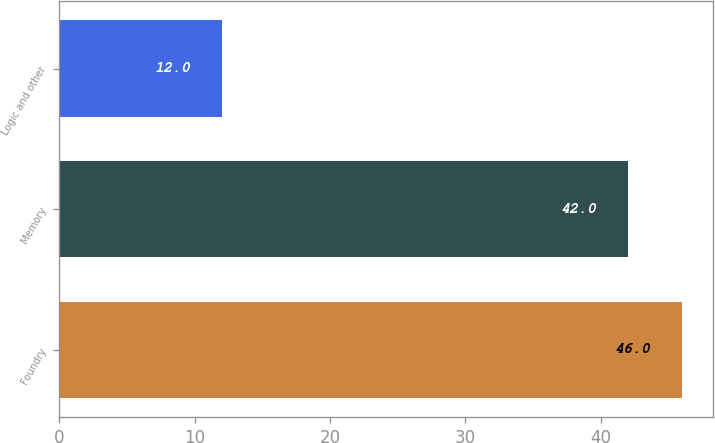Convert chart. <chart><loc_0><loc_0><loc_500><loc_500><bar_chart><fcel>Foundry<fcel>Memory<fcel>Logic and other<nl><fcel>46<fcel>42<fcel>12<nl></chart> 